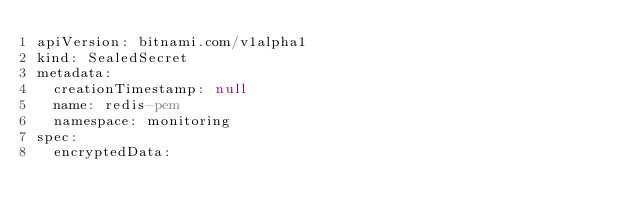Convert code to text. <code><loc_0><loc_0><loc_500><loc_500><_YAML_>apiVersion: bitnami.com/v1alpha1
kind: SealedSecret
metadata:
  creationTimestamp: null
  name: redis-pem
  namespace: monitoring
spec:
  encryptedData:</code> 